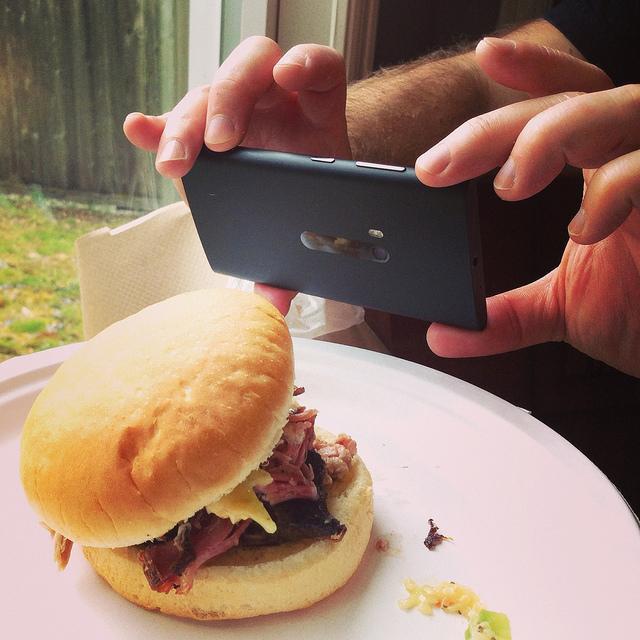Does the description: "The person is touching the sandwich." accurately reflect the image?
Answer yes or no. No. 